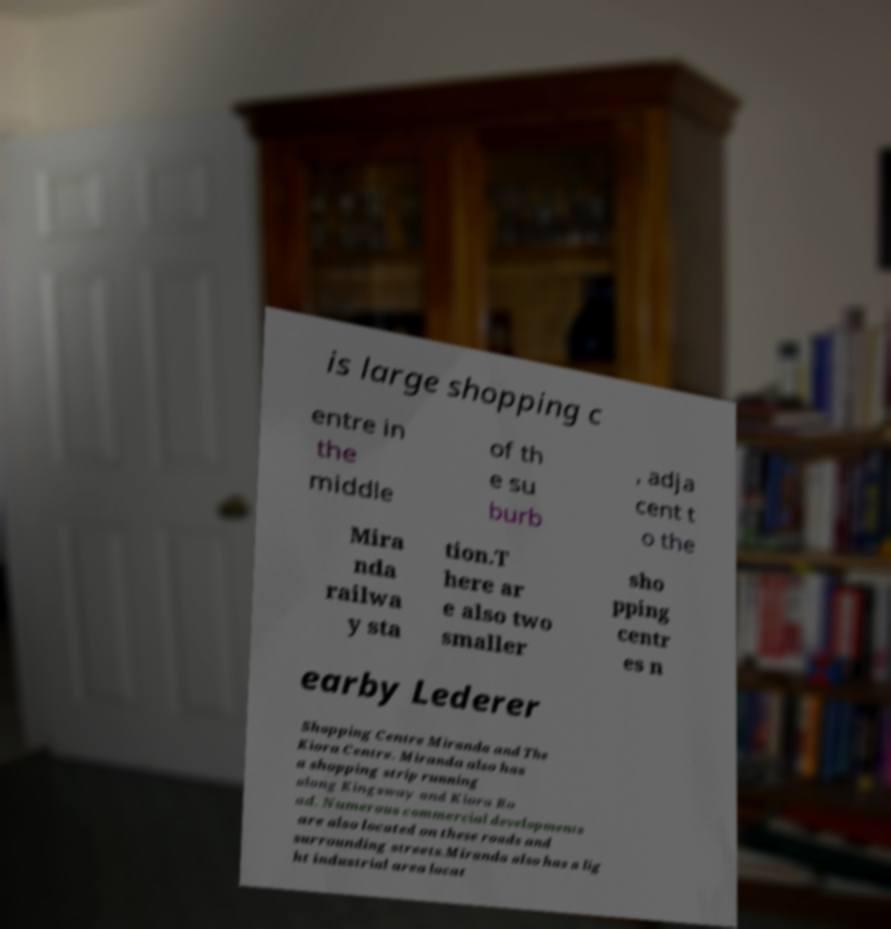Please read and relay the text visible in this image. What does it say? is large shopping c entre in the middle of th e su burb , adja cent t o the Mira nda railwa y sta tion.T here ar e also two smaller sho pping centr es n earby Lederer Shopping Centre Miranda and The Kiora Centre. Miranda also has a shopping strip running along Kingsway and Kiora Ro ad. Numerous commercial developments are also located on these roads and surrounding streets.Miranda also has a lig ht industrial area locat 